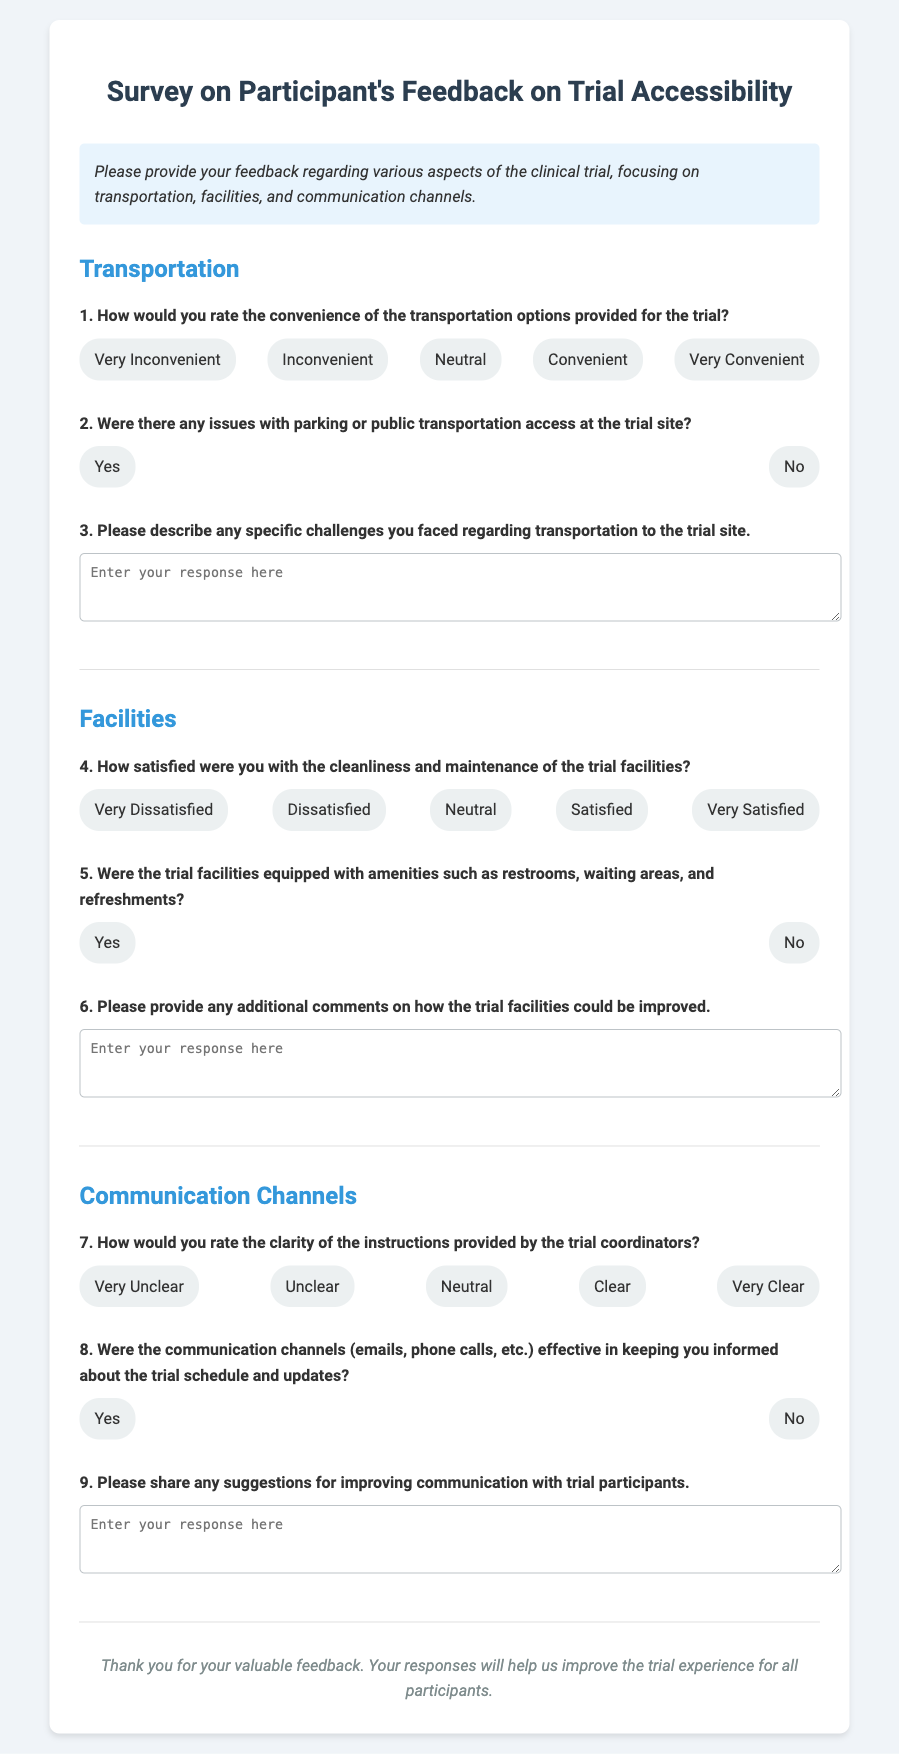What is the title of the survey? The title of the survey is presented at the top of the document.
Answer: Survey on Participant's Feedback on Trial Accessibility How many sections are in the survey? The document is divided into three main sections regarding different aspects of the trial.
Answer: 3 What question number asks about parking or public transportation access? This question is specifically numbered and relates to transportation issues at the trial site.
Answer: 2 What response option indicates a high level of satisfaction with the trial facilities' cleanliness? This option reflects a positive sentiment expressed in the response section.
Answer: Very Satisfied Is there a question asking about the effectiveness of communication channels? The document specifically inquires about the effectiveness of the communication strategies used.
Answer: Yes What is the instruction provided at the beginning of the survey? Instructions on how participants should provide their feedback are given in a dedicated section.
Answer: Please provide your feedback regarding various aspects of the clinical trial, focusing on transportation, facilities, and communication channels How many response options are available for rating the clarity of instructions provided by trial coordinators? The question includes several choices for rating clarity, which indicates the level of understanding.
Answer: 5 What type of feedback does the survey ask for regarding transportation? The survey specifically requests participants to detail any challenges faced related to transportation.
Answer: Challenges What aspect of the trial does the sixth question focus on? The question seeks feedback specifically on facilities and their amenities, providing a targeted inquiry.
Answer: Facilities improvements What suggestion is requested at the end of the communication channels section? The survey prompts participants to offer their recommendations for enhancing communication.
Answer: Suggestions for improving communication with trial participants 